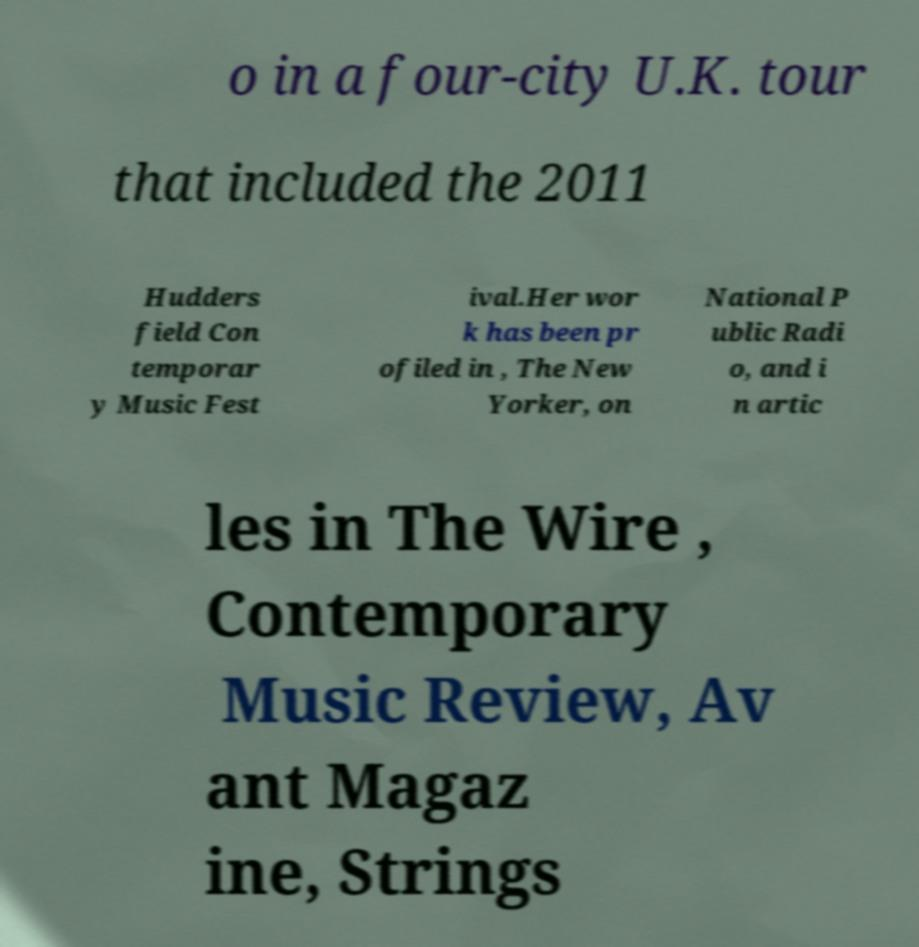There's text embedded in this image that I need extracted. Can you transcribe it verbatim? o in a four-city U.K. tour that included the 2011 Hudders field Con temporar y Music Fest ival.Her wor k has been pr ofiled in , The New Yorker, on National P ublic Radi o, and i n artic les in The Wire , Contemporary Music Review, Av ant Magaz ine, Strings 